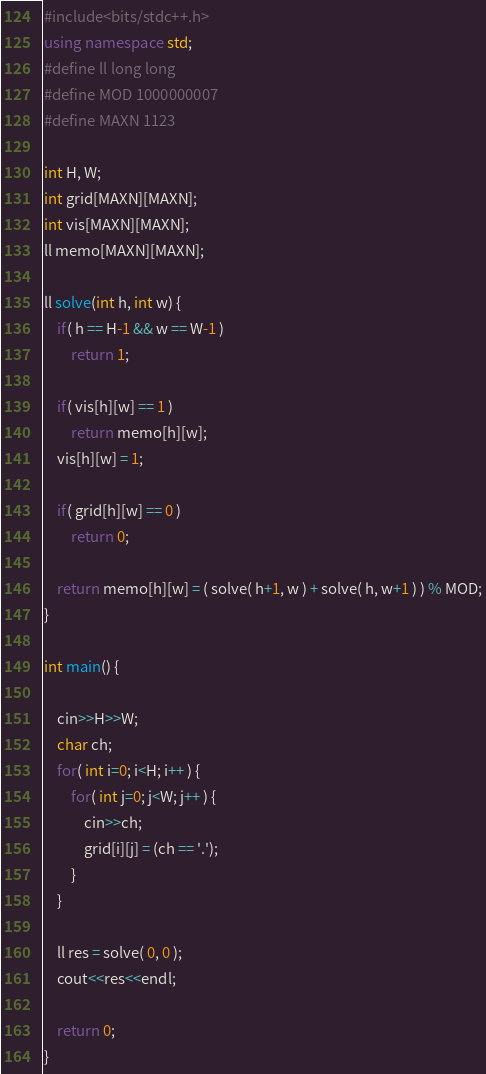Convert code to text. <code><loc_0><loc_0><loc_500><loc_500><_C++_>#include<bits/stdc++.h> 
using namespace std;
#define ll long long
#define MOD 1000000007
#define MAXN 1123
 
int H, W;
int grid[MAXN][MAXN];
int vis[MAXN][MAXN];
ll memo[MAXN][MAXN];

ll solve(int h, int w) {
	if( h == H-1 && w == W-1 )
		return 1;

	if( vis[h][w] == 1 )
		return memo[h][w];
	vis[h][w] = 1;

	if( grid[h][w] == 0 )
		return 0;

	return memo[h][w] = ( solve( h+1, w ) + solve( h, w+1 ) ) % MOD;
}

int main() {
  
  	cin>>H>>W;
  	char ch;
  	for( int i=0; i<H; i++ ) {
  		for( int j=0; j<W; j++ ) {
  			cin>>ch;
  			grid[i][j] = (ch == '.');
  		}
  	}

  	ll res = solve( 0, 0 );
  	cout<<res<<endl;

  	return 0;
}</code> 